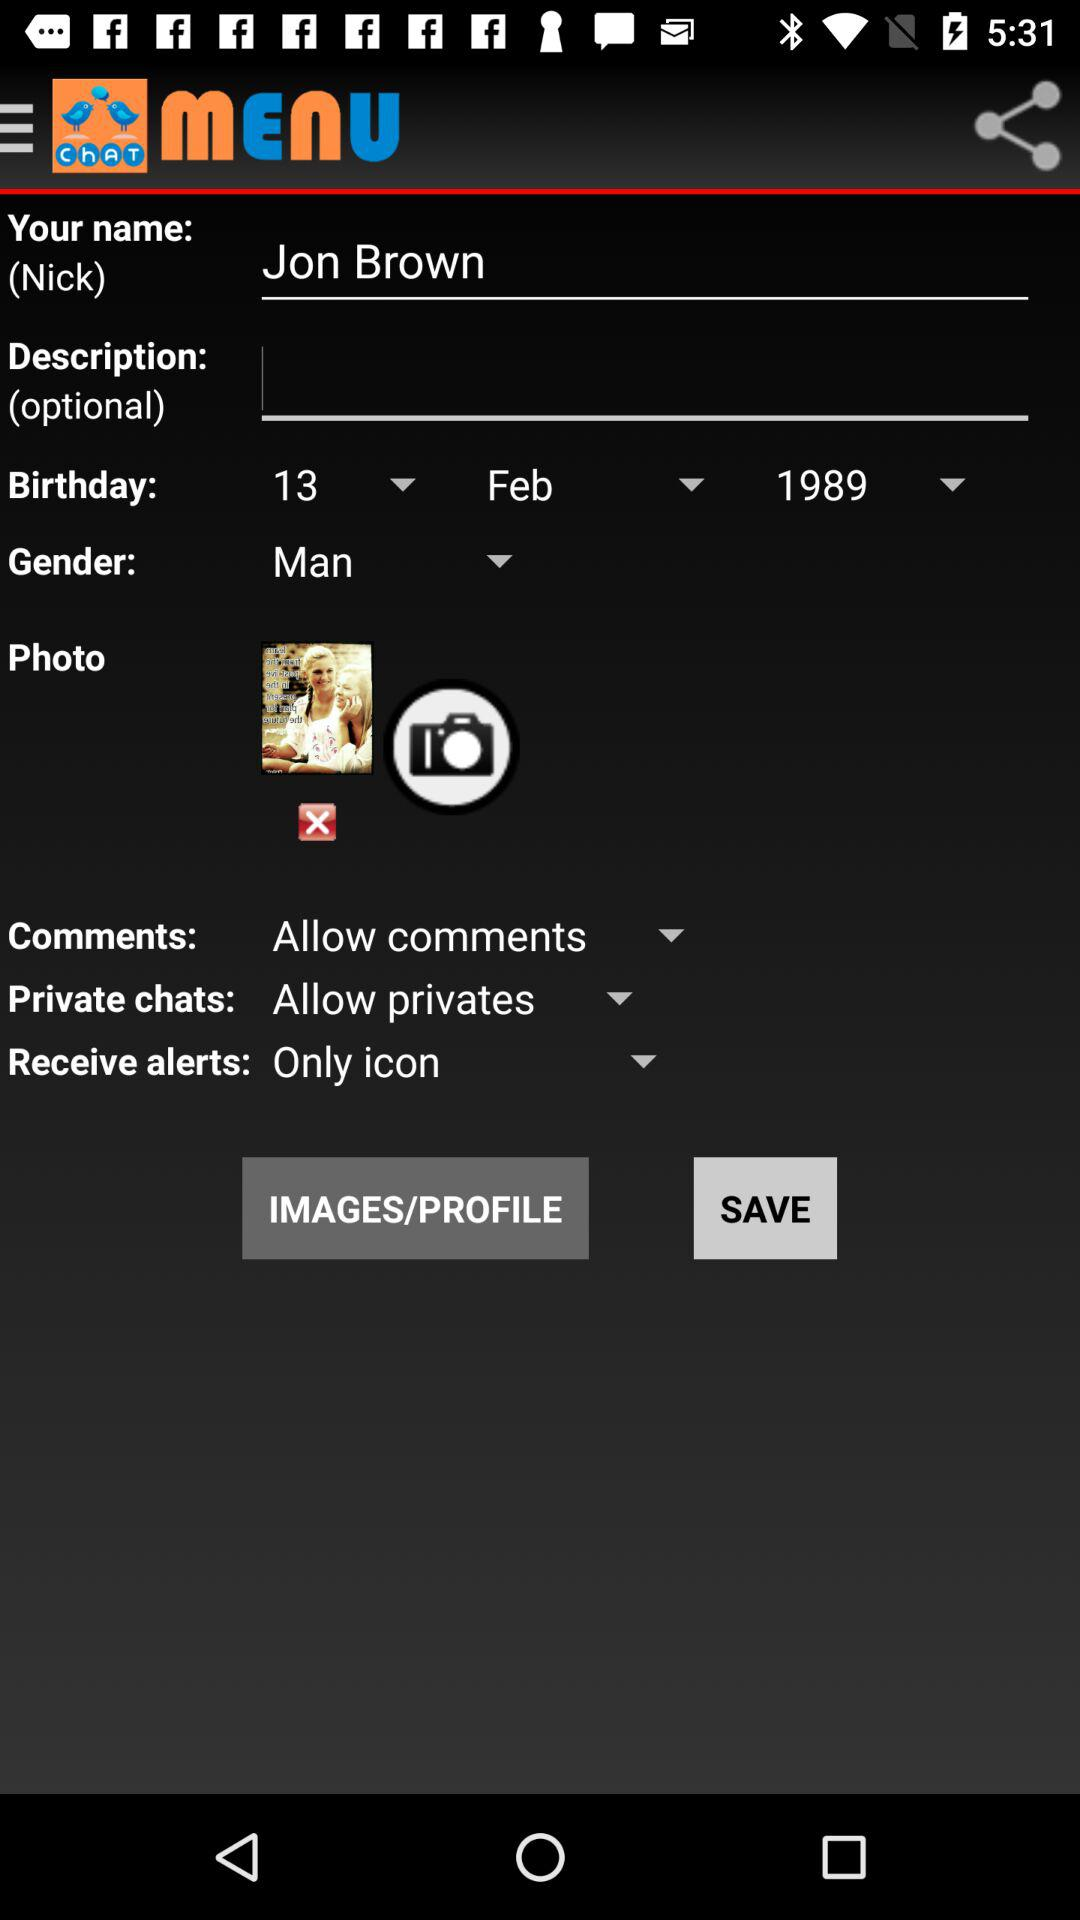What is the selected option for "Receive alerts"? The selected option for "Receive alerts" is "Only icon". 